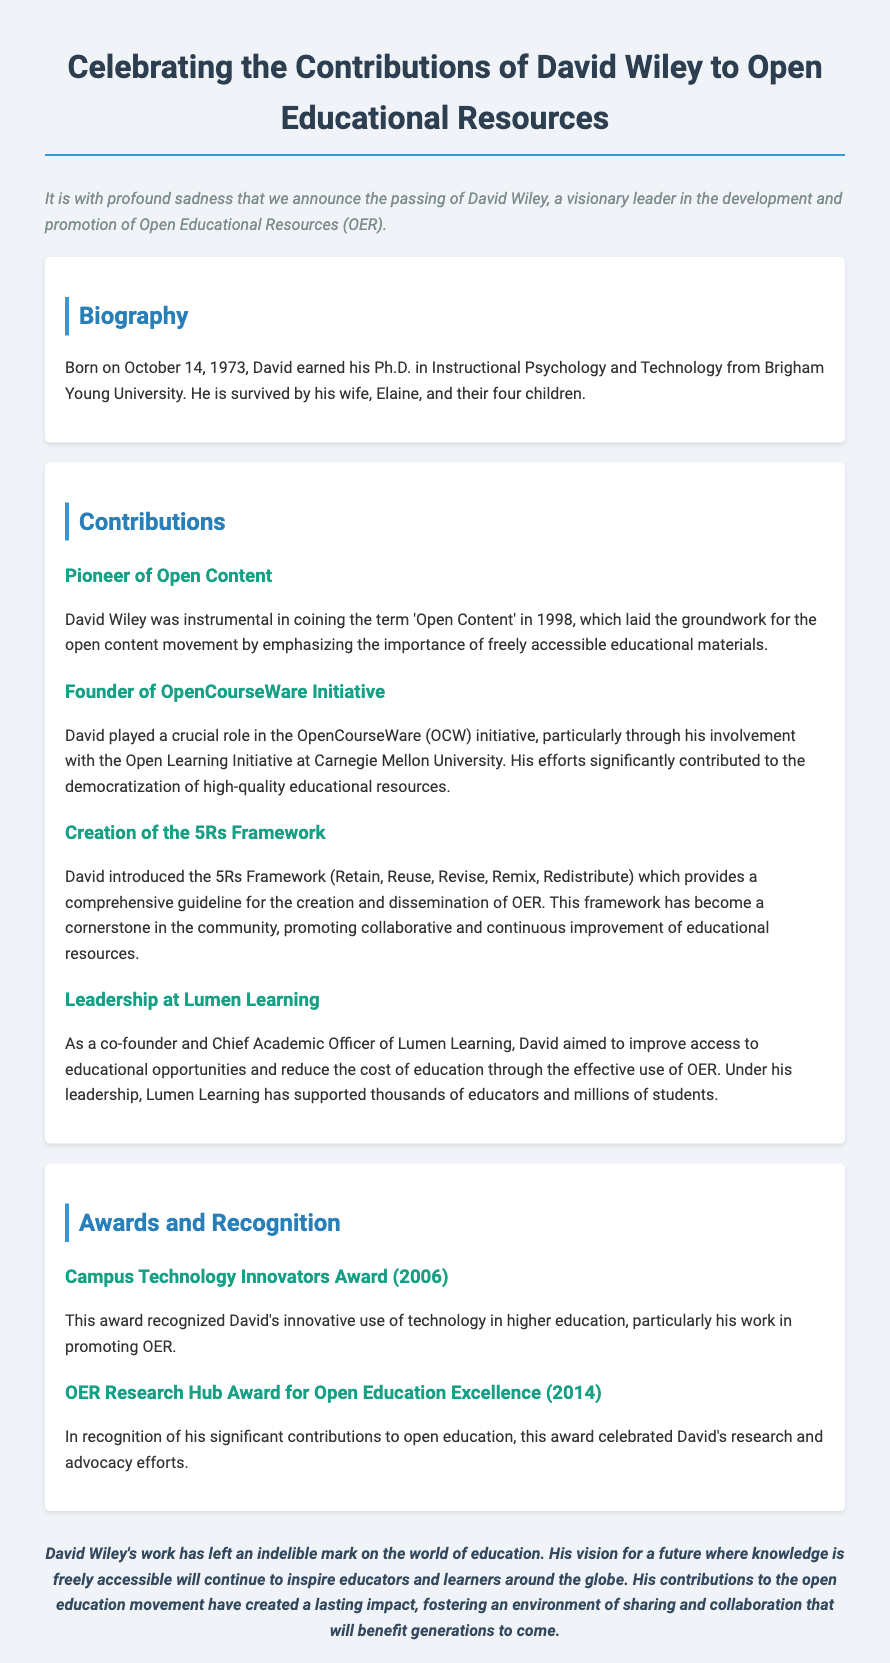What is David Wiley known for? David Wiley is known for being a visionary leader in the development and promotion of Open Educational Resources (OER).
Answer: Open Educational Resources (OER) When was David Wiley born? David Wiley was born on October 14, 1973.
Answer: October 14, 1973 What significant framework did David introduce? David introduced the 5Rs Framework, which includes Retain, Reuse, Revise, Remix, Redistribute for OER.
Answer: 5Rs Framework What award did David Wiley receive in 2006? The award he received in 2006 was the Campus Technology Innovators Award.
Answer: Campus Technology Innovators Award What role did David Wiley hold at Lumen Learning? He was a co-founder and Chief Academic Officer of Lumen Learning.
Answer: Chief Academic Officer Which university did David Wiley earn his Ph.D. from? He earned his Ph.D. from Brigham Young University.
Answer: Brigham Young University How many children did David Wiley have? David Wiley had four children.
Answer: Four children What initiative was David Wiley crucial in? David Wiley played a crucial role in the OpenCourseWare (OCW) initiative.
Answer: OpenCourseWare (OCW) initiative What is one key aspect of David's legacy? His vision for a future where knowledge is freely accessible is a key aspect of his legacy.
Answer: Freely accessible knowledge 